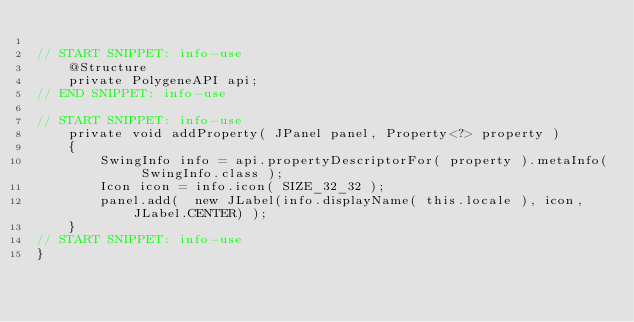<code> <loc_0><loc_0><loc_500><loc_500><_Java_>
// START SNIPPET: info-use
    @Structure
    private PolygeneAPI api;
// END SNIPPET: info-use

// START SNIPPET: info-use
    private void addProperty( JPanel panel, Property<?> property )
    {
        SwingInfo info = api.propertyDescriptorFor( property ).metaInfo( SwingInfo.class );
        Icon icon = info.icon( SIZE_32_32 );
        panel.add(  new JLabel(info.displayName( this.locale ), icon, JLabel.CENTER) );
    }
// START SNIPPET: info-use
}
</code> 